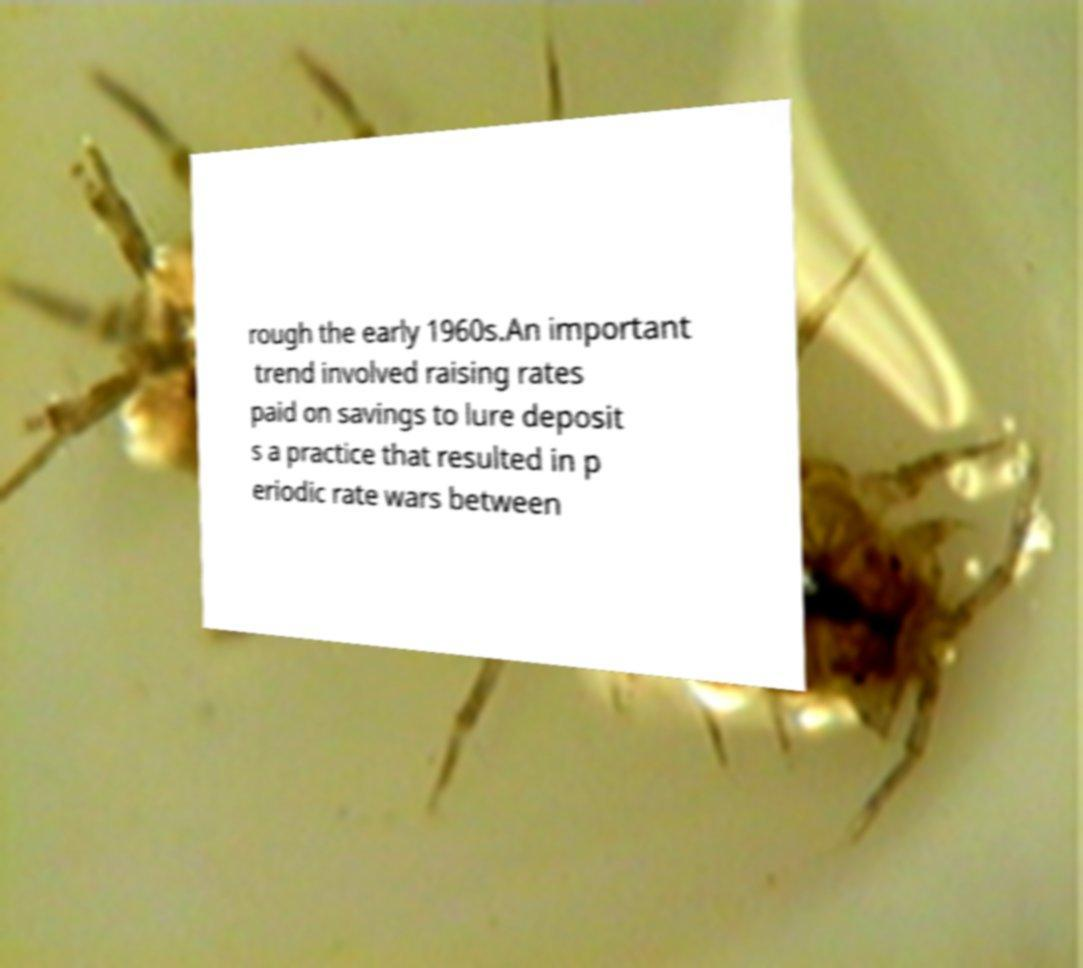There's text embedded in this image that I need extracted. Can you transcribe it verbatim? rough the early 1960s.An important trend involved raising rates paid on savings to lure deposit s a practice that resulted in p eriodic rate wars between 